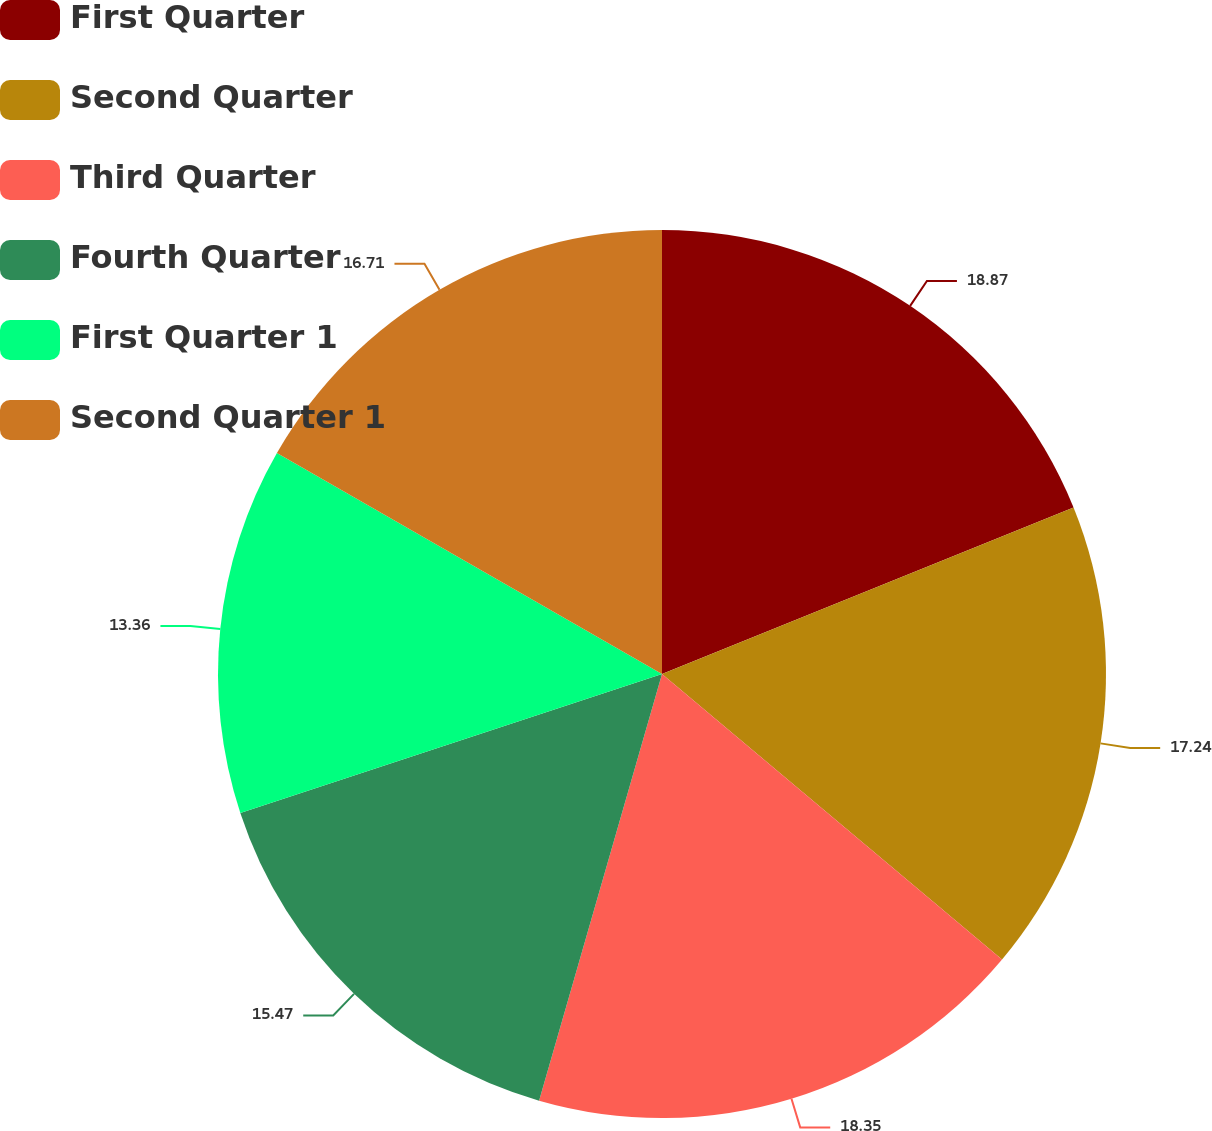Convert chart to OTSL. <chart><loc_0><loc_0><loc_500><loc_500><pie_chart><fcel>First Quarter<fcel>Second Quarter<fcel>Third Quarter<fcel>Fourth Quarter<fcel>First Quarter 1<fcel>Second Quarter 1<nl><fcel>18.88%<fcel>17.24%<fcel>18.35%<fcel>15.47%<fcel>13.36%<fcel>16.71%<nl></chart> 